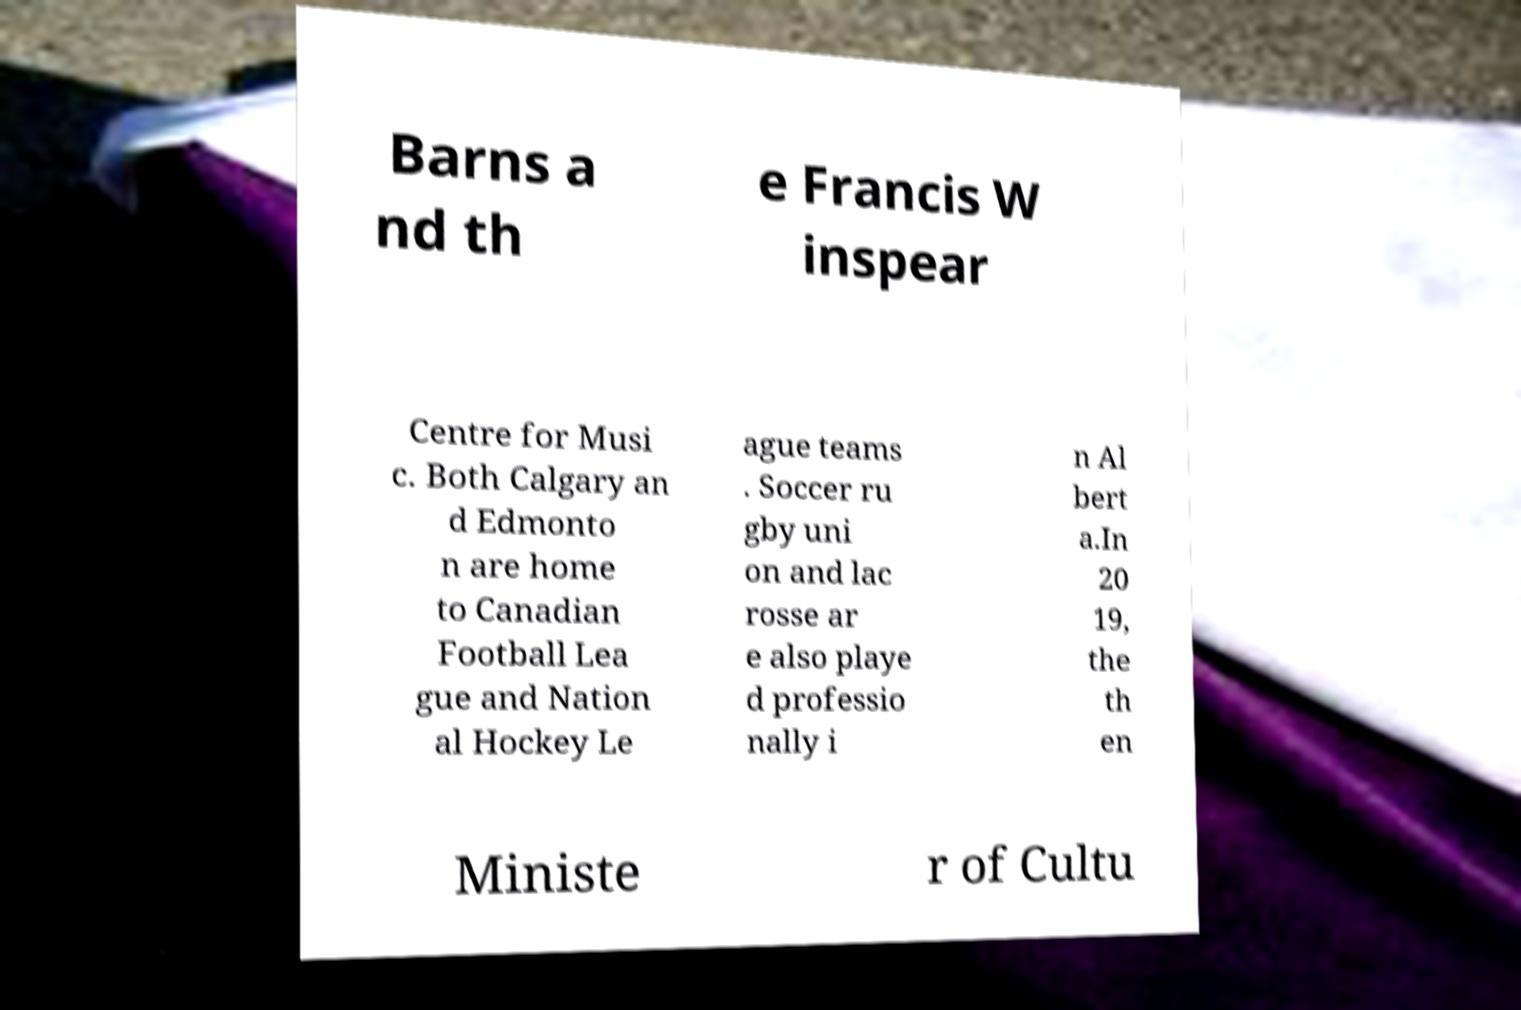Could you extract and type out the text from this image? Barns a nd th e Francis W inspear Centre for Musi c. Both Calgary an d Edmonto n are home to Canadian Football Lea gue and Nation al Hockey Le ague teams . Soccer ru gby uni on and lac rosse ar e also playe d professio nally i n Al bert a.In 20 19, the th en Ministe r of Cultu 